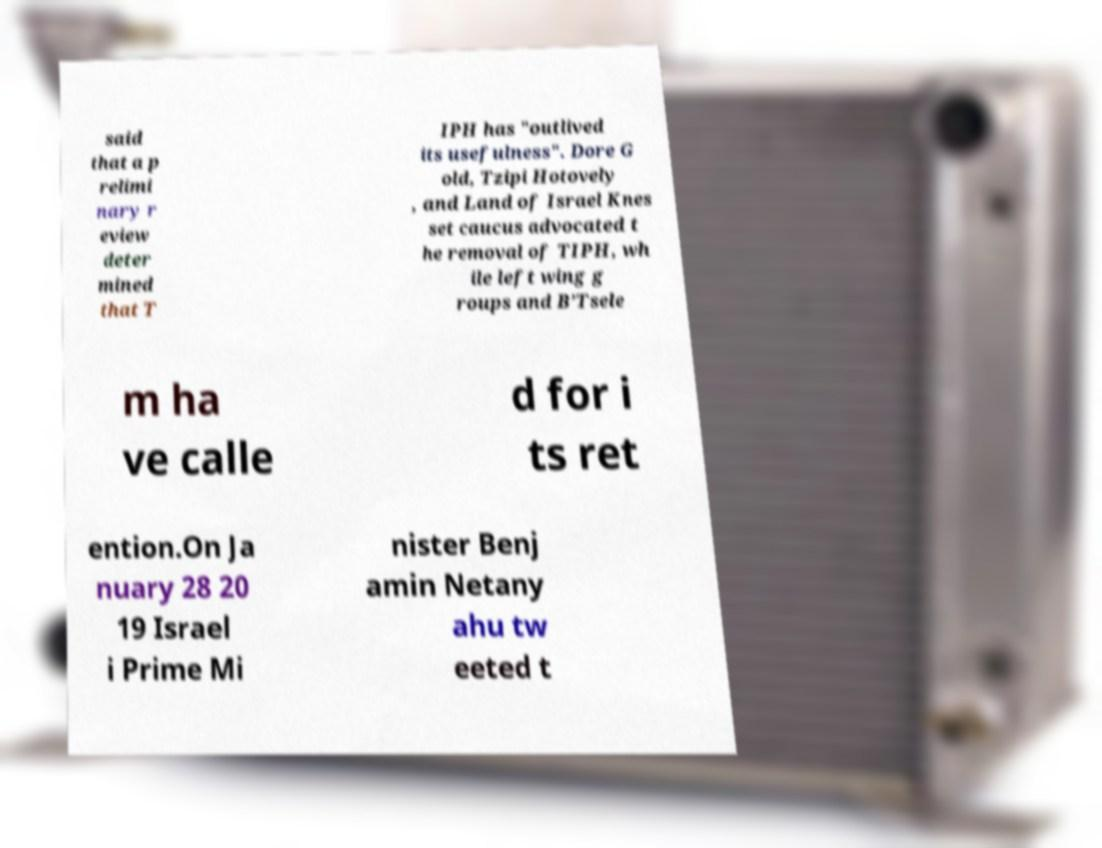For documentation purposes, I need the text within this image transcribed. Could you provide that? said that a p relimi nary r eview deter mined that T IPH has "outlived its usefulness". Dore G old, Tzipi Hotovely , and Land of Israel Knes set caucus advocated t he removal of TIPH, wh ile left wing g roups and B’Tsele m ha ve calle d for i ts ret ention.On Ja nuary 28 20 19 Israel i Prime Mi nister Benj amin Netany ahu tw eeted t 